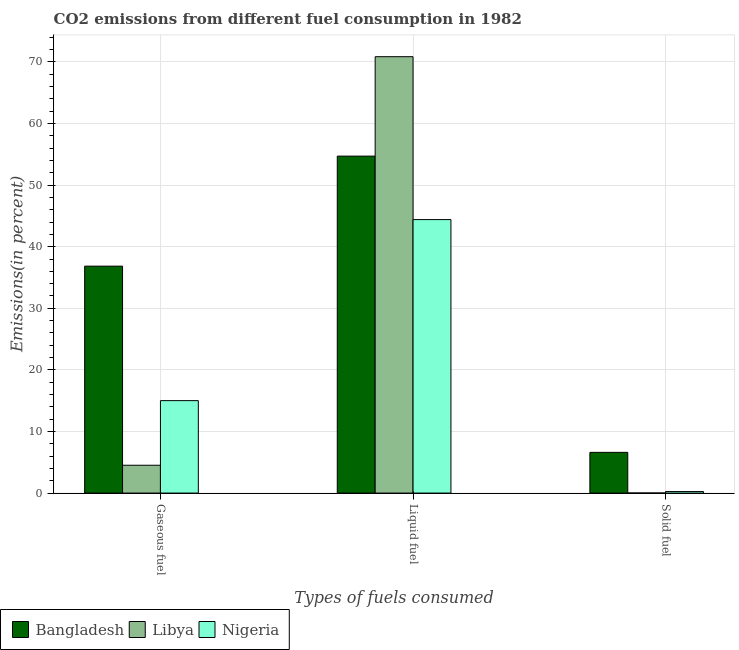Are the number of bars per tick equal to the number of legend labels?
Offer a very short reply. Yes. How many bars are there on the 3rd tick from the right?
Offer a very short reply. 3. What is the label of the 3rd group of bars from the left?
Your answer should be very brief. Solid fuel. What is the percentage of gaseous fuel emission in Nigeria?
Give a very brief answer. 15.01. Across all countries, what is the maximum percentage of gaseous fuel emission?
Provide a succinct answer. 36.84. Across all countries, what is the minimum percentage of gaseous fuel emission?
Your answer should be very brief. 4.52. In which country was the percentage of gaseous fuel emission minimum?
Ensure brevity in your answer.  Libya. What is the total percentage of gaseous fuel emission in the graph?
Your response must be concise. 56.37. What is the difference between the percentage of solid fuel emission in Libya and that in Bangladesh?
Provide a short and direct response. -6.6. What is the difference between the percentage of liquid fuel emission in Nigeria and the percentage of gaseous fuel emission in Bangladesh?
Your response must be concise. 7.56. What is the average percentage of liquid fuel emission per country?
Ensure brevity in your answer.  56.66. What is the difference between the percentage of solid fuel emission and percentage of gaseous fuel emission in Libya?
Provide a succinct answer. -4.51. In how many countries, is the percentage of liquid fuel emission greater than 20 %?
Provide a short and direct response. 3. What is the ratio of the percentage of solid fuel emission in Bangladesh to that in Libya?
Offer a very short reply. 554.5. Is the difference between the percentage of solid fuel emission in Libya and Nigeria greater than the difference between the percentage of liquid fuel emission in Libya and Nigeria?
Give a very brief answer. No. What is the difference between the highest and the second highest percentage of gaseous fuel emission?
Keep it short and to the point. 21.84. What is the difference between the highest and the lowest percentage of solid fuel emission?
Your answer should be very brief. 6.6. In how many countries, is the percentage of liquid fuel emission greater than the average percentage of liquid fuel emission taken over all countries?
Your answer should be very brief. 1. Is the sum of the percentage of solid fuel emission in Bangladesh and Libya greater than the maximum percentage of gaseous fuel emission across all countries?
Your answer should be very brief. No. Are all the bars in the graph horizontal?
Offer a very short reply. No. What is the difference between two consecutive major ticks on the Y-axis?
Keep it short and to the point. 10. Does the graph contain grids?
Provide a short and direct response. Yes. Where does the legend appear in the graph?
Make the answer very short. Bottom left. How many legend labels are there?
Keep it short and to the point. 3. How are the legend labels stacked?
Your answer should be compact. Horizontal. What is the title of the graph?
Ensure brevity in your answer.  CO2 emissions from different fuel consumption in 1982. Does "Other small states" appear as one of the legend labels in the graph?
Give a very brief answer. No. What is the label or title of the X-axis?
Provide a succinct answer. Types of fuels consumed. What is the label or title of the Y-axis?
Ensure brevity in your answer.  Emissions(in percent). What is the Emissions(in percent) of Bangladesh in Gaseous fuel?
Keep it short and to the point. 36.84. What is the Emissions(in percent) of Libya in Gaseous fuel?
Ensure brevity in your answer.  4.52. What is the Emissions(in percent) of Nigeria in Gaseous fuel?
Give a very brief answer. 15.01. What is the Emissions(in percent) of Bangladesh in Liquid fuel?
Provide a short and direct response. 54.71. What is the Emissions(in percent) of Libya in Liquid fuel?
Provide a short and direct response. 70.85. What is the Emissions(in percent) of Nigeria in Liquid fuel?
Give a very brief answer. 44.4. What is the Emissions(in percent) of Bangladesh in Solid fuel?
Your answer should be very brief. 6.61. What is the Emissions(in percent) in Libya in Solid fuel?
Offer a terse response. 0.01. What is the Emissions(in percent) in Nigeria in Solid fuel?
Your answer should be compact. 0.25. Across all Types of fuels consumed, what is the maximum Emissions(in percent) of Bangladesh?
Make the answer very short. 54.71. Across all Types of fuels consumed, what is the maximum Emissions(in percent) of Libya?
Provide a short and direct response. 70.85. Across all Types of fuels consumed, what is the maximum Emissions(in percent) of Nigeria?
Your answer should be very brief. 44.4. Across all Types of fuels consumed, what is the minimum Emissions(in percent) in Bangladesh?
Offer a terse response. 6.61. Across all Types of fuels consumed, what is the minimum Emissions(in percent) in Libya?
Provide a succinct answer. 0.01. Across all Types of fuels consumed, what is the minimum Emissions(in percent) of Nigeria?
Your response must be concise. 0.25. What is the total Emissions(in percent) in Bangladesh in the graph?
Your response must be concise. 98.17. What is the total Emissions(in percent) of Libya in the graph?
Provide a short and direct response. 75.38. What is the total Emissions(in percent) in Nigeria in the graph?
Your answer should be very brief. 59.66. What is the difference between the Emissions(in percent) in Bangladesh in Gaseous fuel and that in Liquid fuel?
Provide a short and direct response. -17.87. What is the difference between the Emissions(in percent) in Libya in Gaseous fuel and that in Liquid fuel?
Make the answer very short. -66.34. What is the difference between the Emissions(in percent) of Nigeria in Gaseous fuel and that in Liquid fuel?
Provide a succinct answer. -29.4. What is the difference between the Emissions(in percent) of Bangladesh in Gaseous fuel and that in Solid fuel?
Provide a short and direct response. 30.23. What is the difference between the Emissions(in percent) in Libya in Gaseous fuel and that in Solid fuel?
Keep it short and to the point. 4.51. What is the difference between the Emissions(in percent) of Nigeria in Gaseous fuel and that in Solid fuel?
Your answer should be very brief. 14.76. What is the difference between the Emissions(in percent) in Bangladesh in Liquid fuel and that in Solid fuel?
Your response must be concise. 48.1. What is the difference between the Emissions(in percent) of Libya in Liquid fuel and that in Solid fuel?
Keep it short and to the point. 70.84. What is the difference between the Emissions(in percent) in Nigeria in Liquid fuel and that in Solid fuel?
Offer a terse response. 44.16. What is the difference between the Emissions(in percent) in Bangladesh in Gaseous fuel and the Emissions(in percent) in Libya in Liquid fuel?
Offer a terse response. -34.01. What is the difference between the Emissions(in percent) in Bangladesh in Gaseous fuel and the Emissions(in percent) in Nigeria in Liquid fuel?
Ensure brevity in your answer.  -7.56. What is the difference between the Emissions(in percent) in Libya in Gaseous fuel and the Emissions(in percent) in Nigeria in Liquid fuel?
Offer a very short reply. -39.89. What is the difference between the Emissions(in percent) of Bangladesh in Gaseous fuel and the Emissions(in percent) of Libya in Solid fuel?
Offer a very short reply. 36.83. What is the difference between the Emissions(in percent) of Bangladesh in Gaseous fuel and the Emissions(in percent) of Nigeria in Solid fuel?
Your answer should be compact. 36.6. What is the difference between the Emissions(in percent) of Libya in Gaseous fuel and the Emissions(in percent) of Nigeria in Solid fuel?
Make the answer very short. 4.27. What is the difference between the Emissions(in percent) of Bangladesh in Liquid fuel and the Emissions(in percent) of Libya in Solid fuel?
Provide a succinct answer. 54.7. What is the difference between the Emissions(in percent) of Bangladesh in Liquid fuel and the Emissions(in percent) of Nigeria in Solid fuel?
Offer a terse response. 54.47. What is the difference between the Emissions(in percent) of Libya in Liquid fuel and the Emissions(in percent) of Nigeria in Solid fuel?
Your response must be concise. 70.61. What is the average Emissions(in percent) in Bangladesh per Types of fuels consumed?
Give a very brief answer. 32.72. What is the average Emissions(in percent) of Libya per Types of fuels consumed?
Make the answer very short. 25.13. What is the average Emissions(in percent) of Nigeria per Types of fuels consumed?
Your answer should be compact. 19.89. What is the difference between the Emissions(in percent) in Bangladesh and Emissions(in percent) in Libya in Gaseous fuel?
Offer a terse response. 32.33. What is the difference between the Emissions(in percent) in Bangladesh and Emissions(in percent) in Nigeria in Gaseous fuel?
Your answer should be very brief. 21.84. What is the difference between the Emissions(in percent) of Libya and Emissions(in percent) of Nigeria in Gaseous fuel?
Your answer should be compact. -10.49. What is the difference between the Emissions(in percent) of Bangladesh and Emissions(in percent) of Libya in Liquid fuel?
Ensure brevity in your answer.  -16.14. What is the difference between the Emissions(in percent) of Bangladesh and Emissions(in percent) of Nigeria in Liquid fuel?
Offer a terse response. 10.31. What is the difference between the Emissions(in percent) of Libya and Emissions(in percent) of Nigeria in Liquid fuel?
Provide a succinct answer. 26.45. What is the difference between the Emissions(in percent) in Bangladesh and Emissions(in percent) in Libya in Solid fuel?
Offer a very short reply. 6.6. What is the difference between the Emissions(in percent) of Bangladesh and Emissions(in percent) of Nigeria in Solid fuel?
Your answer should be very brief. 6.36. What is the difference between the Emissions(in percent) in Libya and Emissions(in percent) in Nigeria in Solid fuel?
Ensure brevity in your answer.  -0.23. What is the ratio of the Emissions(in percent) in Bangladesh in Gaseous fuel to that in Liquid fuel?
Your answer should be very brief. 0.67. What is the ratio of the Emissions(in percent) of Libya in Gaseous fuel to that in Liquid fuel?
Give a very brief answer. 0.06. What is the ratio of the Emissions(in percent) in Nigeria in Gaseous fuel to that in Liquid fuel?
Give a very brief answer. 0.34. What is the ratio of the Emissions(in percent) of Bangladesh in Gaseous fuel to that in Solid fuel?
Offer a very short reply. 5.57. What is the ratio of the Emissions(in percent) of Libya in Gaseous fuel to that in Solid fuel?
Your response must be concise. 379. What is the ratio of the Emissions(in percent) of Nigeria in Gaseous fuel to that in Solid fuel?
Keep it short and to the point. 61.02. What is the ratio of the Emissions(in percent) in Bangladesh in Liquid fuel to that in Solid fuel?
Your response must be concise. 8.28. What is the ratio of the Emissions(in percent) in Libya in Liquid fuel to that in Solid fuel?
Your answer should be very brief. 5944. What is the ratio of the Emissions(in percent) in Nigeria in Liquid fuel to that in Solid fuel?
Make the answer very short. 180.55. What is the difference between the highest and the second highest Emissions(in percent) in Bangladesh?
Offer a very short reply. 17.87. What is the difference between the highest and the second highest Emissions(in percent) of Libya?
Ensure brevity in your answer.  66.34. What is the difference between the highest and the second highest Emissions(in percent) of Nigeria?
Give a very brief answer. 29.4. What is the difference between the highest and the lowest Emissions(in percent) in Bangladesh?
Provide a short and direct response. 48.1. What is the difference between the highest and the lowest Emissions(in percent) of Libya?
Give a very brief answer. 70.84. What is the difference between the highest and the lowest Emissions(in percent) of Nigeria?
Make the answer very short. 44.16. 